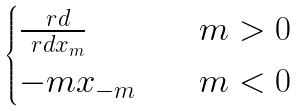Convert formula to latex. <formula><loc_0><loc_0><loc_500><loc_500>\begin{cases} \frac { \ r d } { \ r d x _ { m } } & \quad m > 0 \\ - m x _ { - m } & \quad m < 0 \end{cases}</formula> 